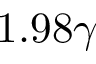Convert formula to latex. <formula><loc_0><loc_0><loc_500><loc_500>1 . 9 8 \gamma</formula> 